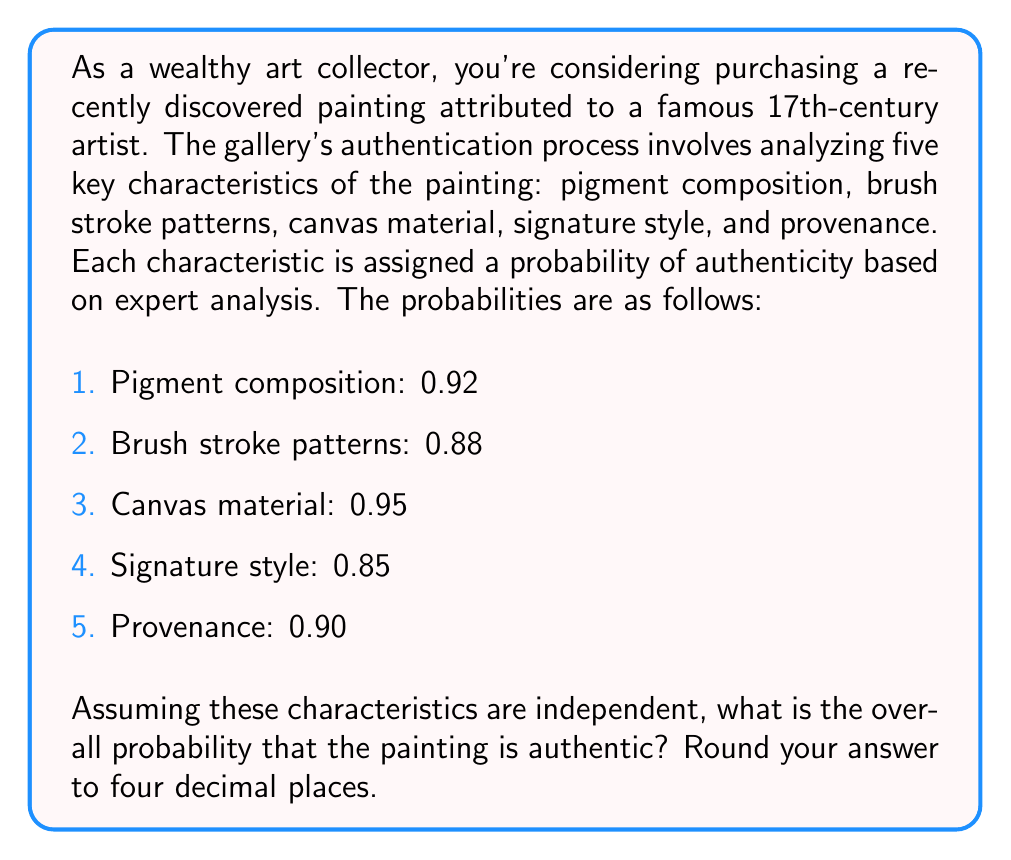Teach me how to tackle this problem. To solve this problem, we need to use the multiplication rule for independent events. Since all five characteristics need to be authentic for the painting to be genuine, we multiply the probabilities of each characteristic being authentic.

Let's define the events:
- A: Pigment composition is authentic
- B: Brush stroke patterns are authentic
- C: Canvas material is authentic
- D: Signature style is authentic
- E: Provenance is authentic

The probability of the painting being authentic is:

$$P(\text{Authentic}) = P(A \cap B \cap C \cap D \cap E)$$

Since the events are independent:

$$P(\text{Authentic}) = P(A) \times P(B) \times P(C) \times P(D) \times P(E)$$

Substituting the given probabilities:

$$P(\text{Authentic}) = 0.92 \times 0.88 \times 0.95 \times 0.85 \times 0.90$$

Calculating:

$$P(\text{Authentic}) = 0.5991768$$

Rounding to four decimal places:

$$P(\text{Authentic}) \approx 0.5992$$

Therefore, the overall probability that the painting is authentic is approximately 0.5992 or 59.92%.
Answer: 0.5992 